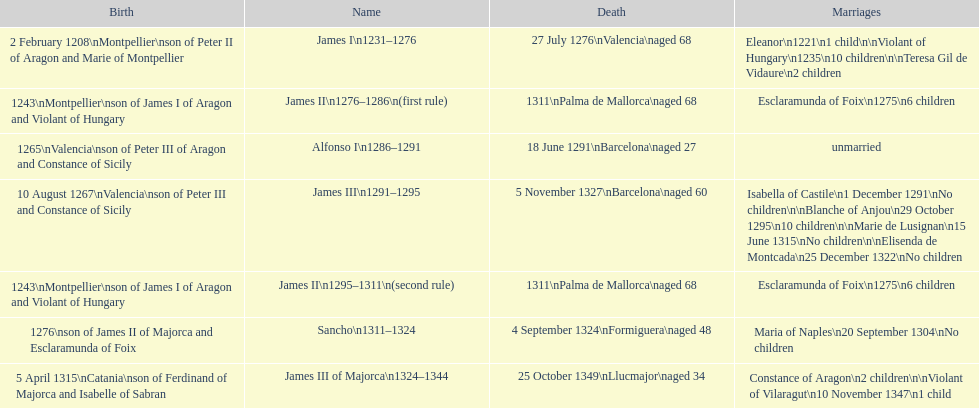How many total marriages did james i have? 3. 